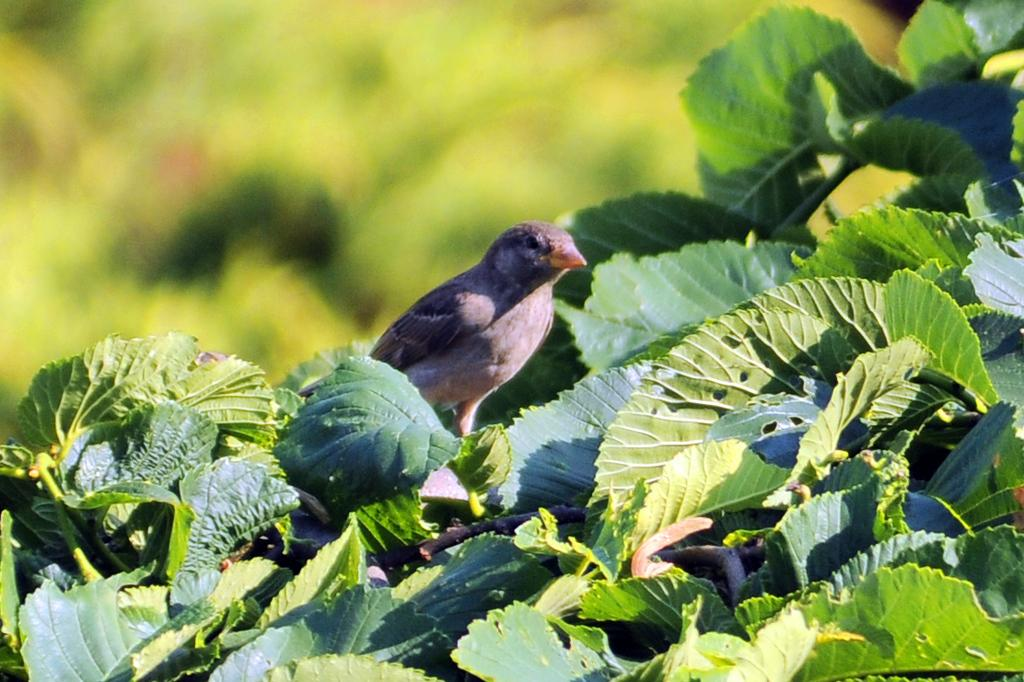What type of animal is in the image? There is a bird in the image. Where is the bird located? The bird is on a tree. Can you describe the background of the image? The background of the image is blurry. What type of chess piece is the bird in the image? There is no chess piece present in the image; it features a bird on a tree. Who is the partner of the bird in the image? There is no partner mentioned or depicted in the image; it only shows a bird on a tree. 